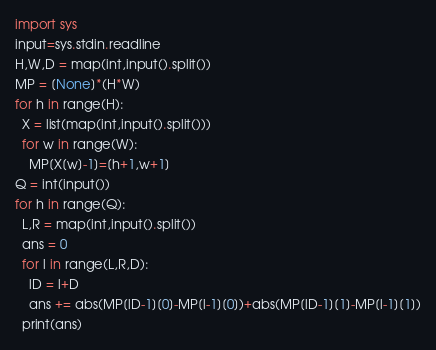Convert code to text. <code><loc_0><loc_0><loc_500><loc_500><_Python_>import sys
input=sys.stdin.readline
H,W,D = map(int,input().split())
MP = [None]*(H*W)
for h in range(H):
  X = list(map(int,input().split()))
  for w in range(W):
    MP[X[w]-1]=[h+1,w+1]
Q = int(input())
for h in range(Q):
  L,R = map(int,input().split())
  ans = 0
  for l in range(L,R,D):
    lD = l+D
    ans += abs(MP[lD-1][0]-MP[l-1][0])+abs(MP[lD-1][1]-MP[l-1][1])
  print(ans)</code> 